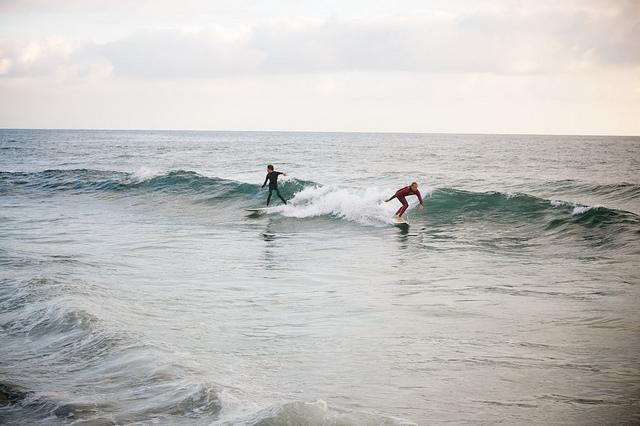How many people are in this photo?
Give a very brief answer. 2. 